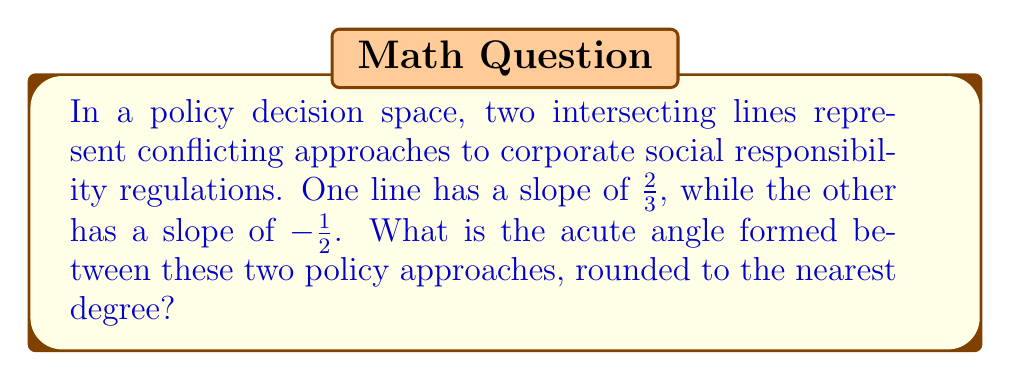Give your solution to this math problem. To find the angle between two intersecting lines, we can use the formula:

$$\tan \theta = \left|\frac{m_1 - m_2}{1 + m_1m_2}\right|$$

Where $m_1$ and $m_2$ are the slopes of the two lines, and $\theta$ is the angle between them.

Step 1: Identify the slopes
$m_1 = \frac{2}{3}$
$m_2 = -\frac{1}{2}$

Step 2: Substitute into the formula
$$\tan \theta = \left|\frac{\frac{2}{3} - (-\frac{1}{2})}{1 + \frac{2}{3}(-\frac{1}{2})}\right|$$

Step 3: Simplify the numerator and denominator
$$\tan \theta = \left|\frac{\frac{2}{3} + \frac{1}{2}}{1 - \frac{1}{3}}\right| = \left|\frac{\frac{4}{6} + \frac{3}{6}}{\frac{2}{3}}\right| = \left|\frac{\frac{7}{6}}{\frac{2}{3}}\right|$$

Step 4: Divide the fractions
$$\tan \theta = \left|\frac{7}{6} \cdot \frac{3}{2}\right| = \left|\frac{21}{12}\right| = \frac{7}{4} = 1.75$$

Step 5: Calculate the inverse tangent (arctangent) and convert to degrees
$$\theta = \arctan(1.75) \approx 60.255^{\circ}$$

Step 6: Round to the nearest degree
$$\theta \approx 60^{\circ}$$
Answer: $60^{\circ}$ 